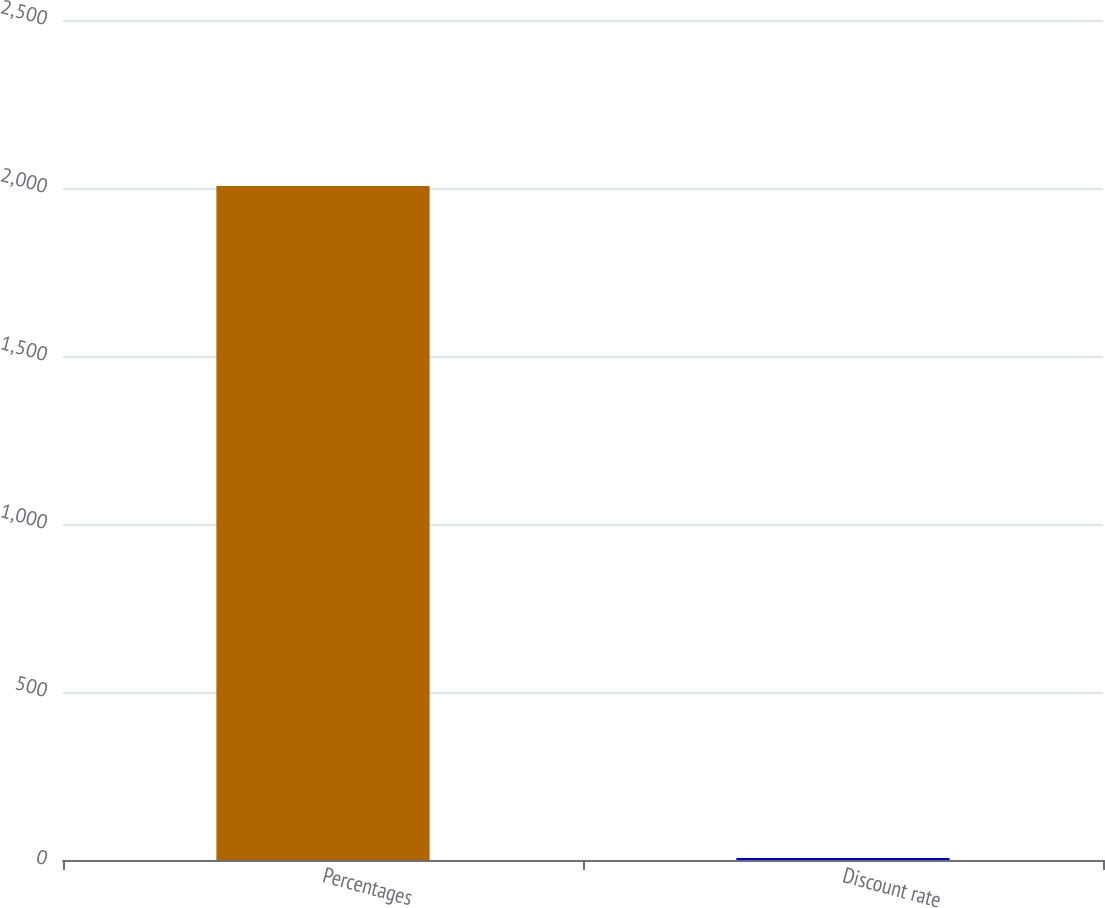Convert chart to OTSL. <chart><loc_0><loc_0><loc_500><loc_500><bar_chart><fcel>Percentages<fcel>Discount rate<nl><fcel>2006<fcel>6<nl></chart> 